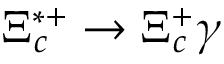Convert formula to latex. <formula><loc_0><loc_0><loc_500><loc_500>\Xi _ { c } ^ { * + } \to \Xi _ { c } ^ { + } \gamma</formula> 